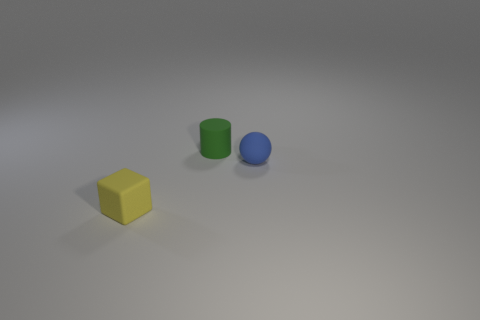Is the number of matte objects to the left of the rubber cylinder greater than the number of green cylinders in front of the blue matte sphere?
Your answer should be very brief. Yes. What number of things are things to the right of the green thing or blue matte things?
Keep it short and to the point. 1. The tiny green object that is the same material as the blue ball is what shape?
Offer a very short reply. Cylinder. Is there any other thing that has the same shape as the blue rubber object?
Ensure brevity in your answer.  No. There is a tiny matte thing that is to the left of the blue ball and in front of the small rubber cylinder; what color is it?
Keep it short and to the point. Yellow. How many cylinders are small yellow matte things or small rubber objects?
Make the answer very short. 1. What number of blue cubes are the same size as the sphere?
Your answer should be compact. 0. What number of blue matte objects are behind the rubber thing that is in front of the tiny blue thing?
Offer a terse response. 1. What size is the matte thing that is to the left of the small sphere and to the right of the yellow matte block?
Provide a short and direct response. Small. Is the number of tiny cylinders greater than the number of large green matte blocks?
Keep it short and to the point. Yes. 